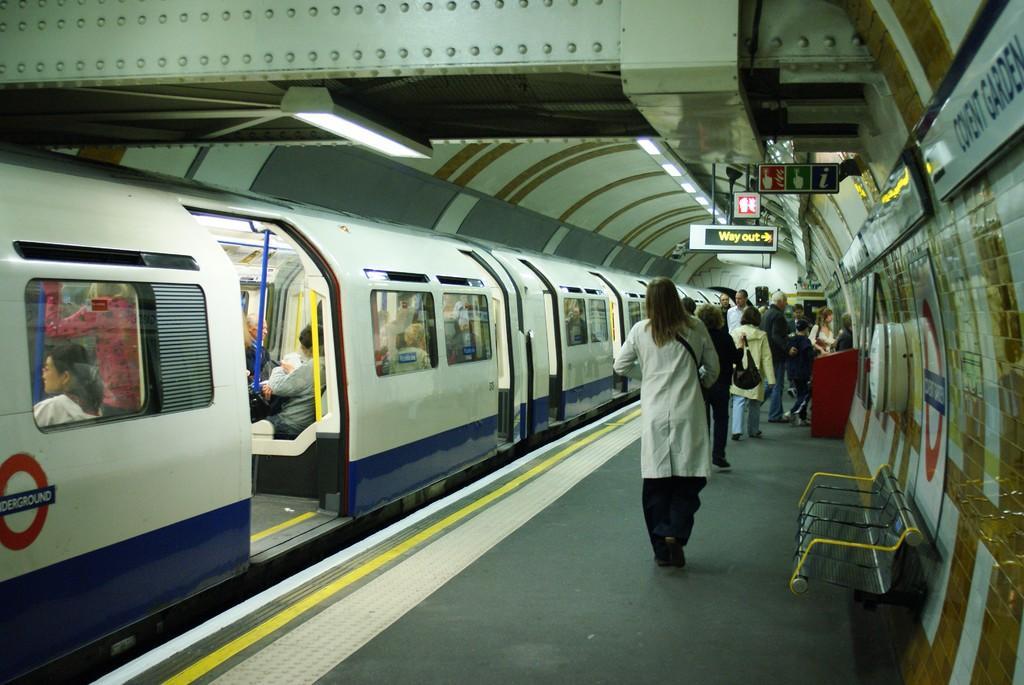How would you summarize this image in a sentence or two? In this picture I can see the platform in front on which there are number of people and I can see a bench. On the left side of this picture I can see train and I see people inside. On the top of this picture I can see the lights and I can see few sign boards and I can see a screen, on which there are words written. 